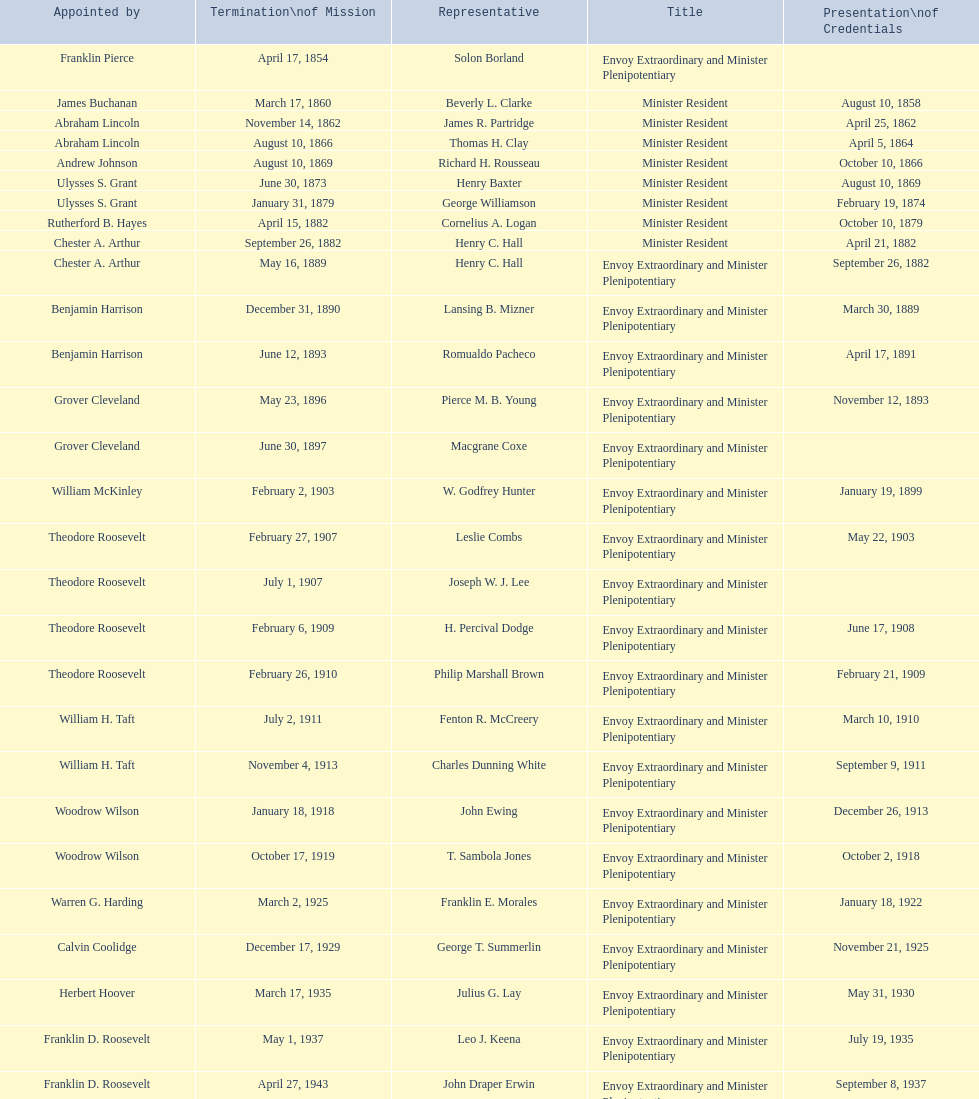How many total representatives have there been? 50. 